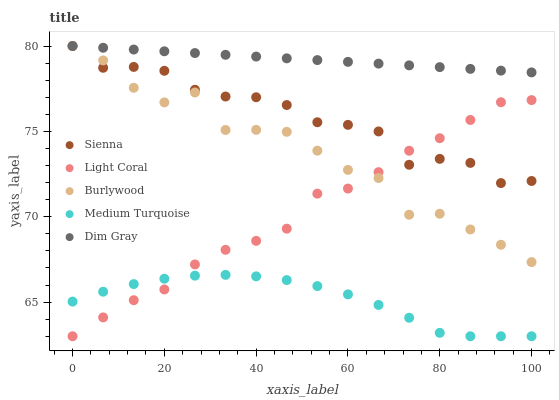Does Medium Turquoise have the minimum area under the curve?
Answer yes or no. Yes. Does Dim Gray have the maximum area under the curve?
Answer yes or no. Yes. Does Light Coral have the minimum area under the curve?
Answer yes or no. No. Does Light Coral have the maximum area under the curve?
Answer yes or no. No. Is Dim Gray the smoothest?
Answer yes or no. Yes. Is Burlywood the roughest?
Answer yes or no. Yes. Is Light Coral the smoothest?
Answer yes or no. No. Is Light Coral the roughest?
Answer yes or no. No. Does Light Coral have the lowest value?
Answer yes or no. Yes. Does Dim Gray have the lowest value?
Answer yes or no. No. Does Burlywood have the highest value?
Answer yes or no. Yes. Does Light Coral have the highest value?
Answer yes or no. No. Is Medium Turquoise less than Dim Gray?
Answer yes or no. Yes. Is Dim Gray greater than Medium Turquoise?
Answer yes or no. Yes. Does Dim Gray intersect Sienna?
Answer yes or no. Yes. Is Dim Gray less than Sienna?
Answer yes or no. No. Is Dim Gray greater than Sienna?
Answer yes or no. No. Does Medium Turquoise intersect Dim Gray?
Answer yes or no. No. 